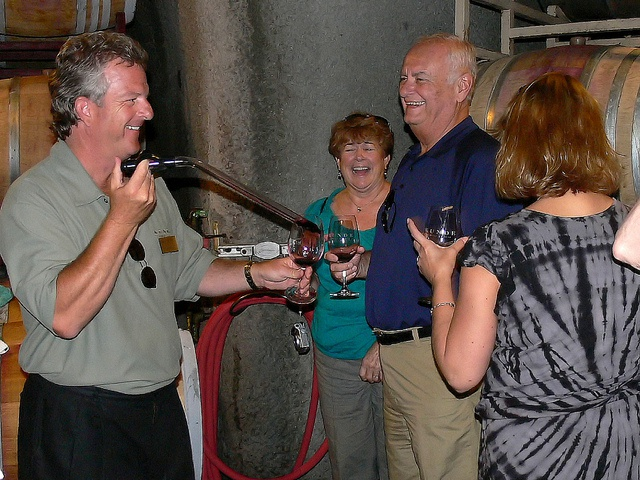Describe the objects in this image and their specific colors. I can see people in gray, black, and salmon tones, people in gray, black, and maroon tones, people in gray, navy, and black tones, people in gray, teal, brown, and black tones, and wine glass in gray, black, maroon, and teal tones in this image. 